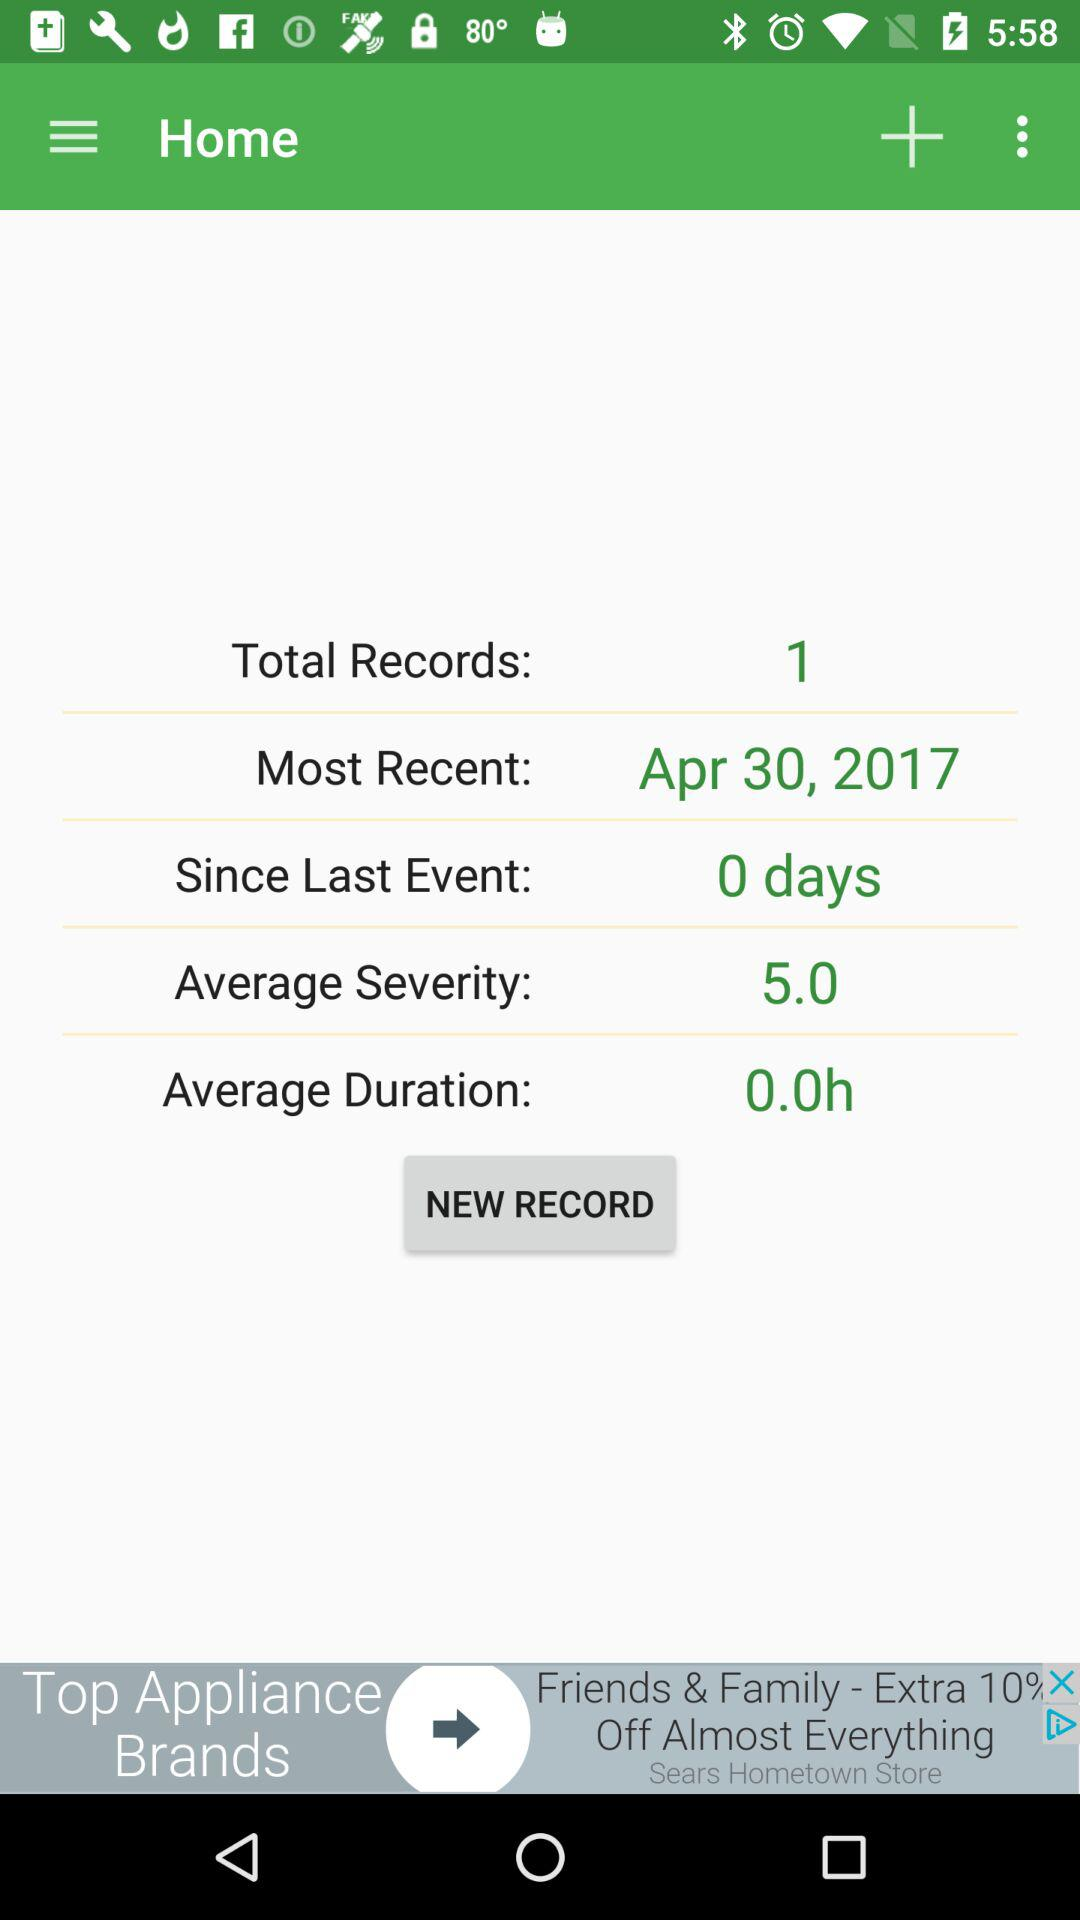How many records are there?
Answer the question using a single word or phrase. 1 